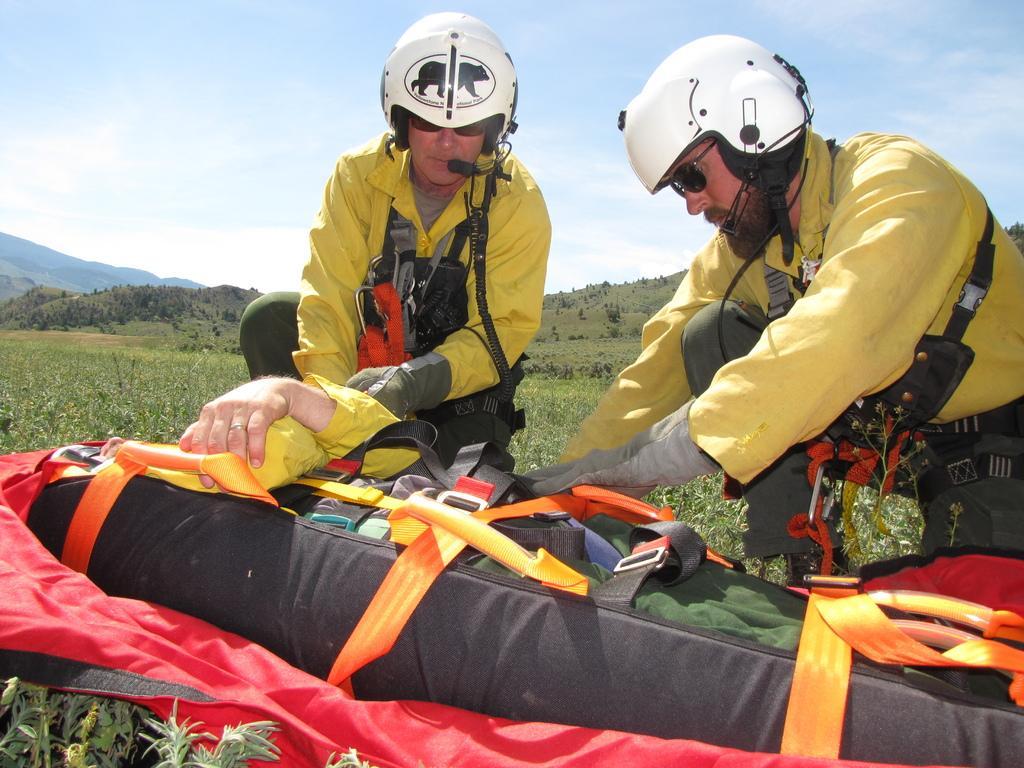Please provide a concise description of this image. In this picture we can see two men on the path. We can see a person on a stretcher/person carry bag. There are some plants and a few trees in the background. 